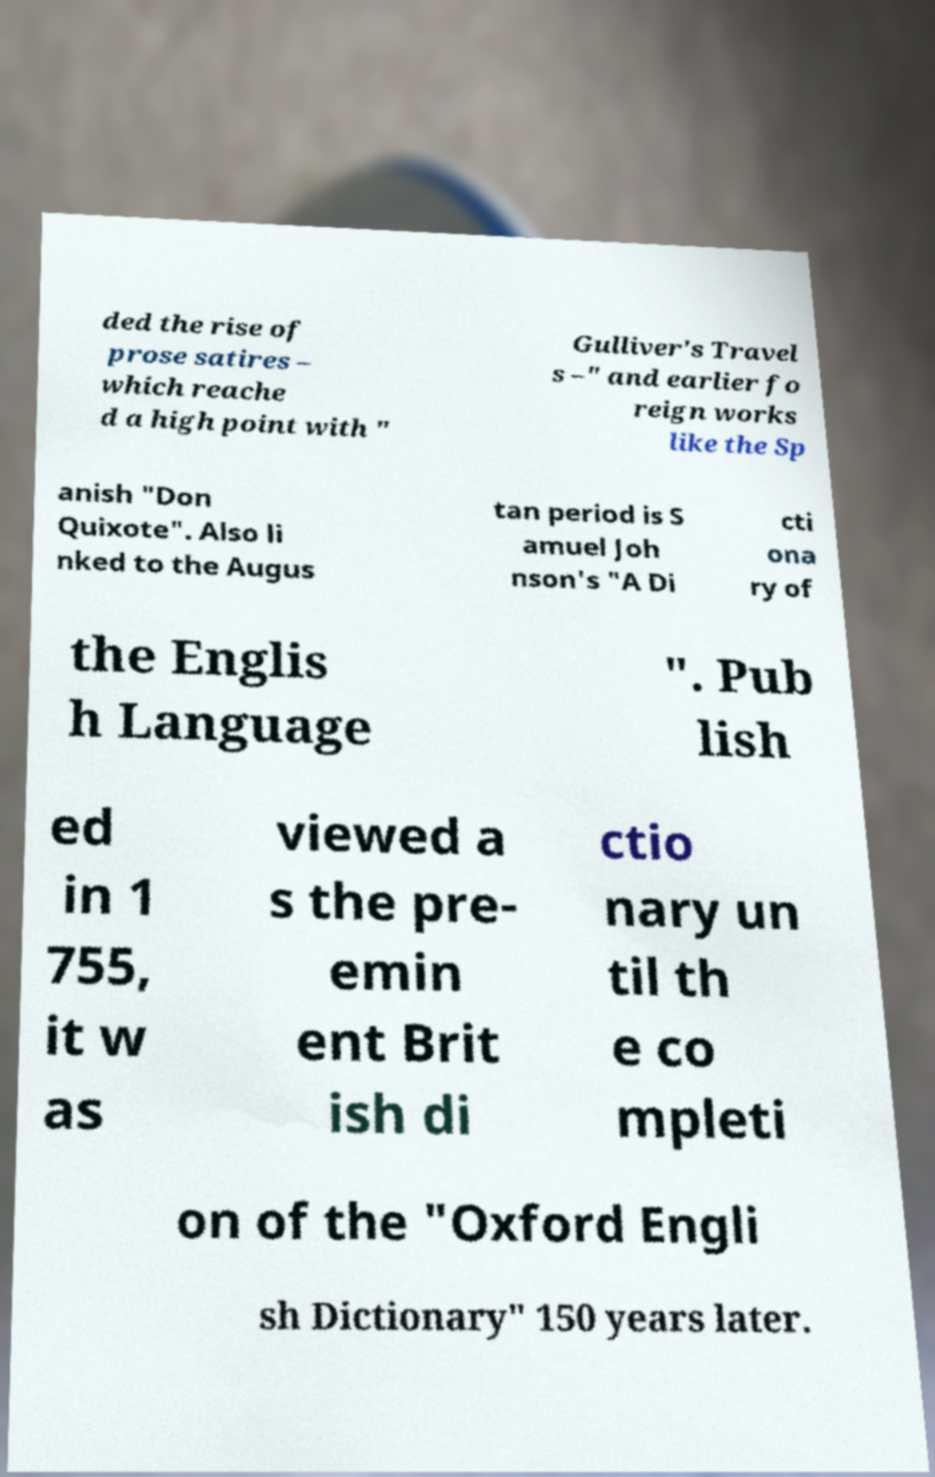Could you extract and type out the text from this image? ded the rise of prose satires – which reache d a high point with " Gulliver's Travel s –" and earlier fo reign works like the Sp anish "Don Quixote". Also li nked to the Augus tan period is S amuel Joh nson's "A Di cti ona ry of the Englis h Language ". Pub lish ed in 1 755, it w as viewed a s the pre- emin ent Brit ish di ctio nary un til th e co mpleti on of the "Oxford Engli sh Dictionary" 150 years later. 